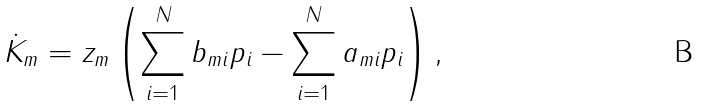<formula> <loc_0><loc_0><loc_500><loc_500>\dot { K } _ { m } = z _ { m } \left ( \sum _ { i = 1 } ^ { N } b _ { m i } p _ { i } - \sum _ { i = 1 } ^ { N } a _ { m i } p _ { i } \right ) ,</formula> 